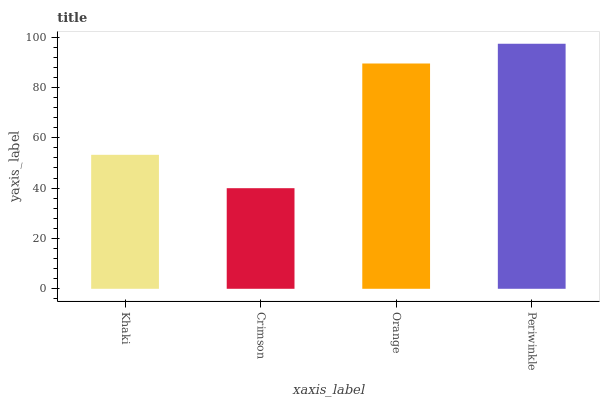Is Crimson the minimum?
Answer yes or no. Yes. Is Periwinkle the maximum?
Answer yes or no. Yes. Is Orange the minimum?
Answer yes or no. No. Is Orange the maximum?
Answer yes or no. No. Is Orange greater than Crimson?
Answer yes or no. Yes. Is Crimson less than Orange?
Answer yes or no. Yes. Is Crimson greater than Orange?
Answer yes or no. No. Is Orange less than Crimson?
Answer yes or no. No. Is Orange the high median?
Answer yes or no. Yes. Is Khaki the low median?
Answer yes or no. Yes. Is Periwinkle the high median?
Answer yes or no. No. Is Orange the low median?
Answer yes or no. No. 